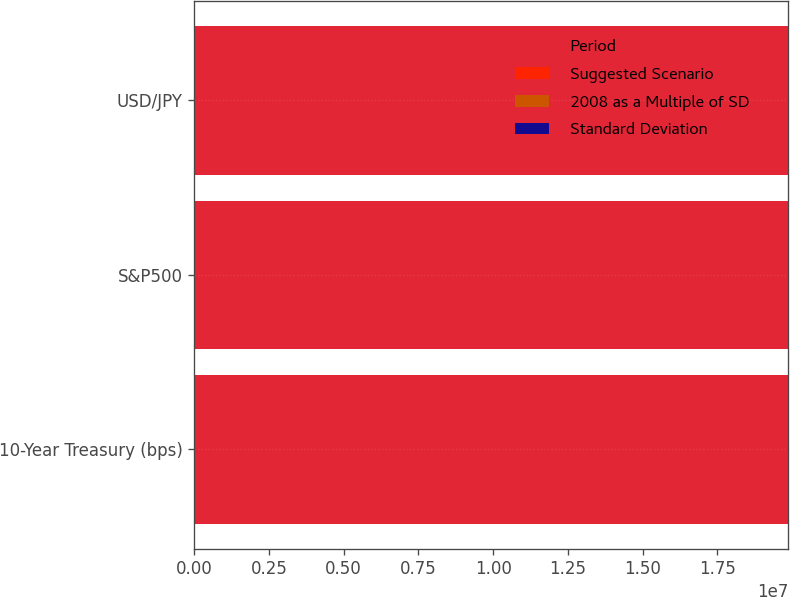<chart> <loc_0><loc_0><loc_500><loc_500><stacked_bar_chart><ecel><fcel>10-Year Treasury (bps)<fcel>S&P500<fcel>USD/JPY<nl><fcel>Period<fcel>1.9872e+07<fcel>1.9872e+07<fcel>1.9872e+07<nl><fcel>Suggested Scenario<fcel>98.1<fcel>16.1<fcel>10<nl><fcel>2008 as a Multiple of SD<fcel>100<fcel>15<fcel>10<nl><fcel>Standard Deviation<fcel>1<fcel>0.9<fcel>1<nl></chart> 